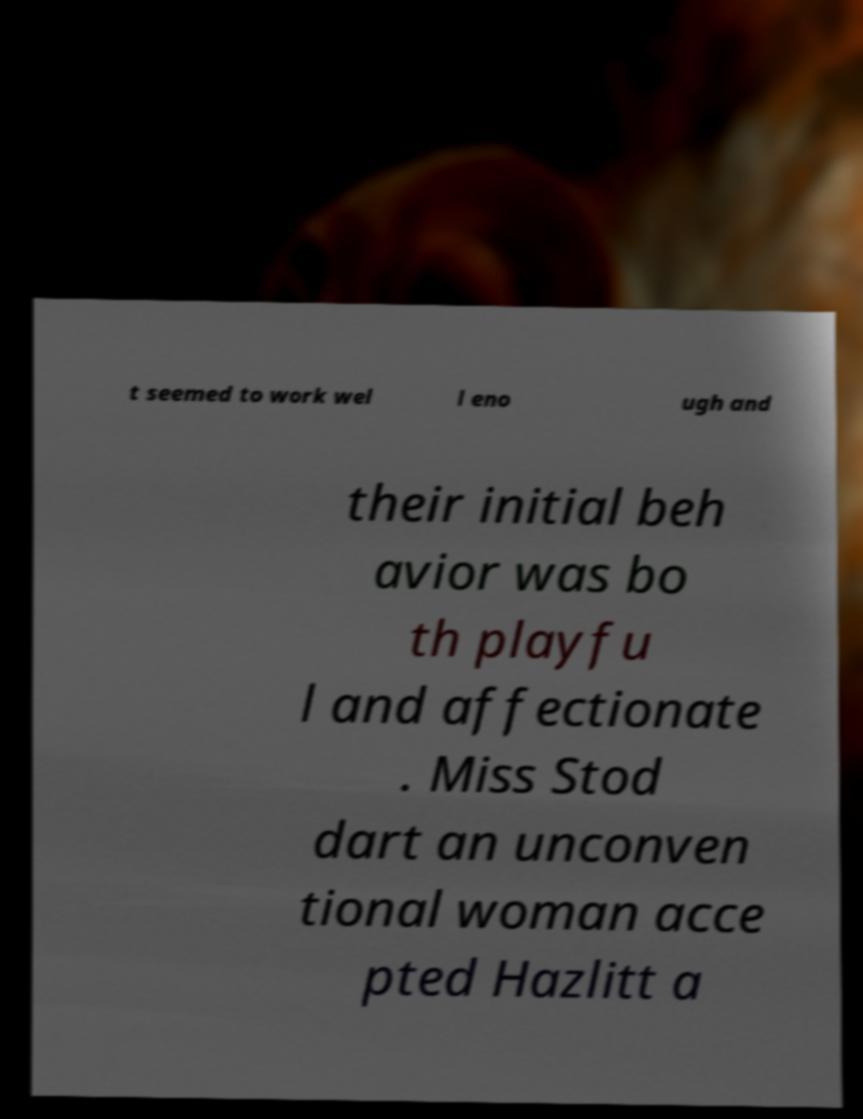There's text embedded in this image that I need extracted. Can you transcribe it verbatim? t seemed to work wel l eno ugh and their initial beh avior was bo th playfu l and affectionate . Miss Stod dart an unconven tional woman acce pted Hazlitt a 